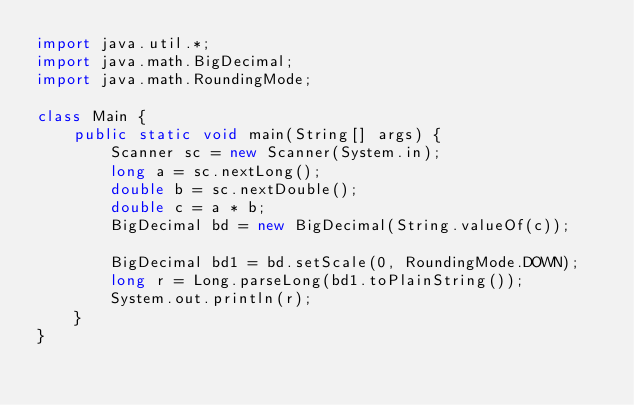Convert code to text. <code><loc_0><loc_0><loc_500><loc_500><_Java_>import java.util.*;
import java.math.BigDecimal;
import java.math.RoundingMode;

class Main {
    public static void main(String[] args) {
        Scanner sc = new Scanner(System.in);
        long a = sc.nextLong();
        double b = sc.nextDouble();
      	double c = a * b;
		BigDecimal bd = new BigDecimal(String.valueOf(c));
		
		BigDecimal bd1 = bd.setScale(0, RoundingMode.DOWN);
      	long r = Long.parseLong(bd1.toPlainString());
        System.out.println(r);
    }
}</code> 